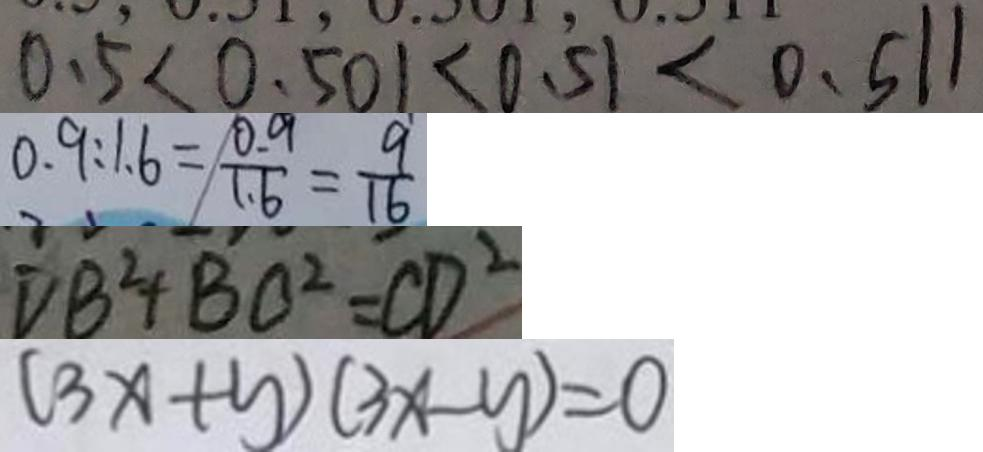Convert formula to latex. <formula><loc_0><loc_0><loc_500><loc_500>0 . 5 < 0 . 5 0 1 < 0 . 5 1 < 0 . 5 1 1 
 0 . 9 : 1 6 = \frac { 0 . 9 } { 1 . 6 } = \frac { 9 } { 1 6 } 
 D B ^ { 2 } + B C ^ { 2 } = C D ^ { 2 } 
 ( 3 x + y ) ( 3 x - y ) = 0</formula> 